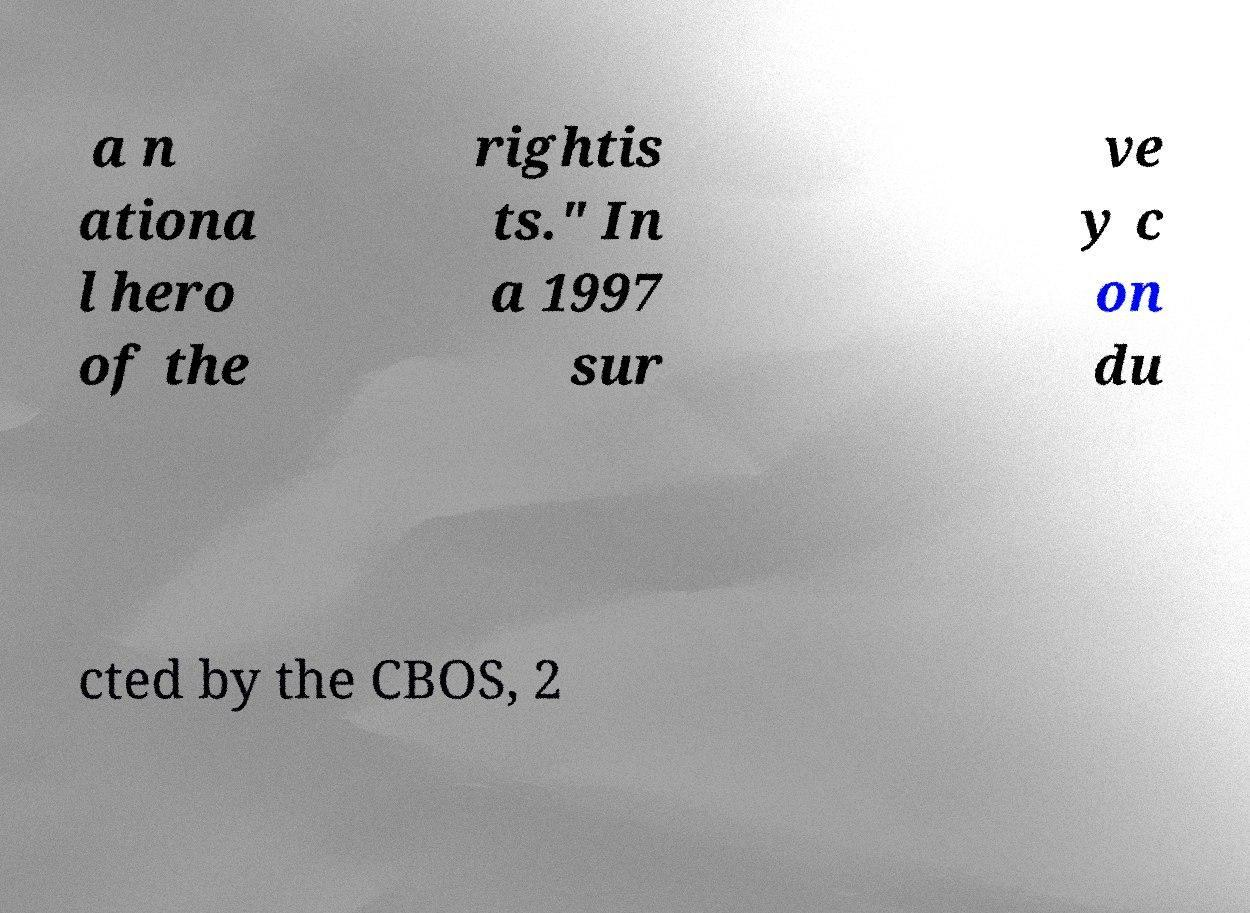What messages or text are displayed in this image? I need them in a readable, typed format. a n ationa l hero of the rightis ts." In a 1997 sur ve y c on du cted by the CBOS, 2 